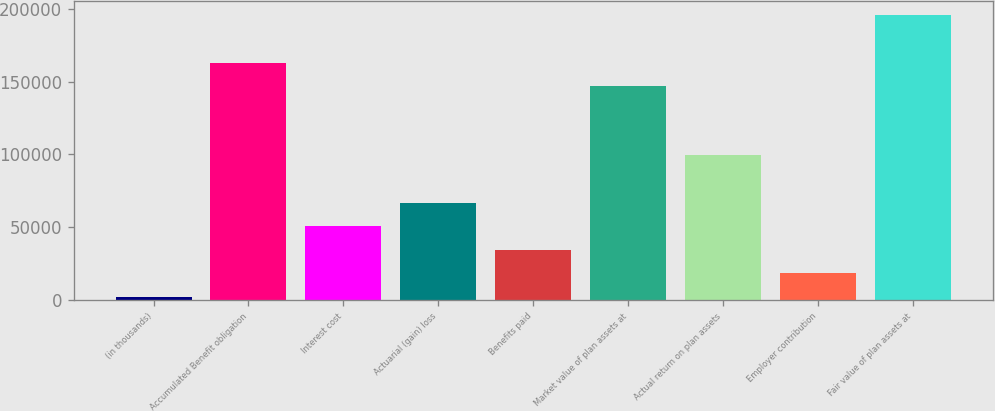Convert chart. <chart><loc_0><loc_0><loc_500><loc_500><bar_chart><fcel>(in thousands)<fcel>Accumulated Benefit obligation<fcel>Interest cost<fcel>Actuarial (gain) loss<fcel>Benefits paid<fcel>Market value of plan assets at<fcel>Actual return on plan assets<fcel>Employer contribution<fcel>Fair value of plan assets at<nl><fcel>2007<fcel>162885<fcel>50705.4<fcel>66938.2<fcel>34472.6<fcel>146652<fcel>99403.8<fcel>18239.8<fcel>195350<nl></chart> 